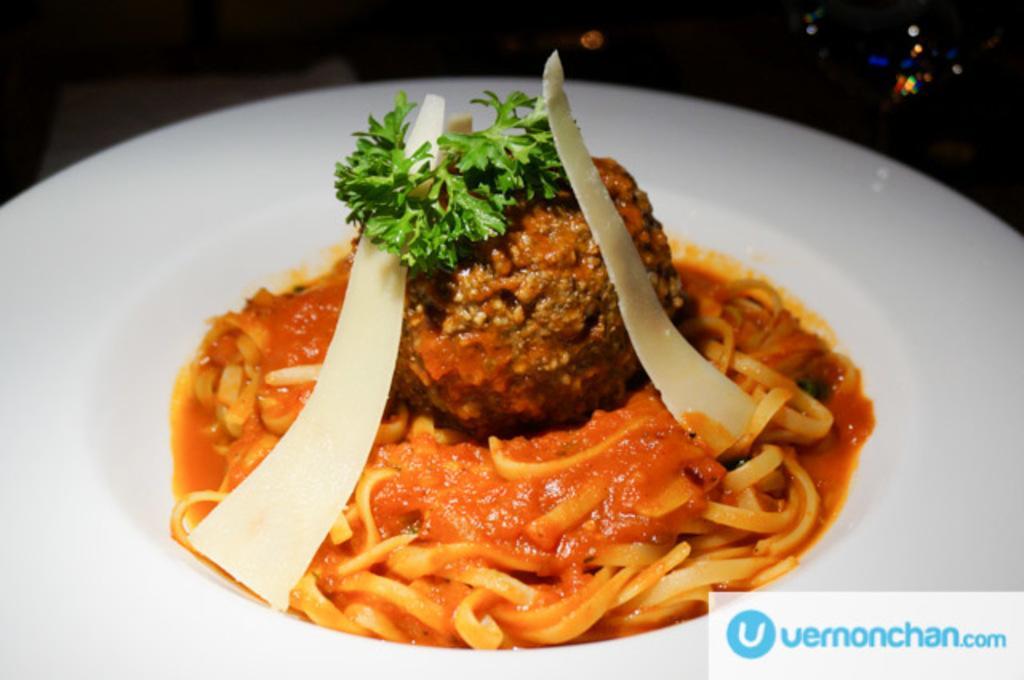Describe this image in one or two sentences. In this image I can see the food in the plate and the food is in orange, brown, green and white color and the plate is in white color. 